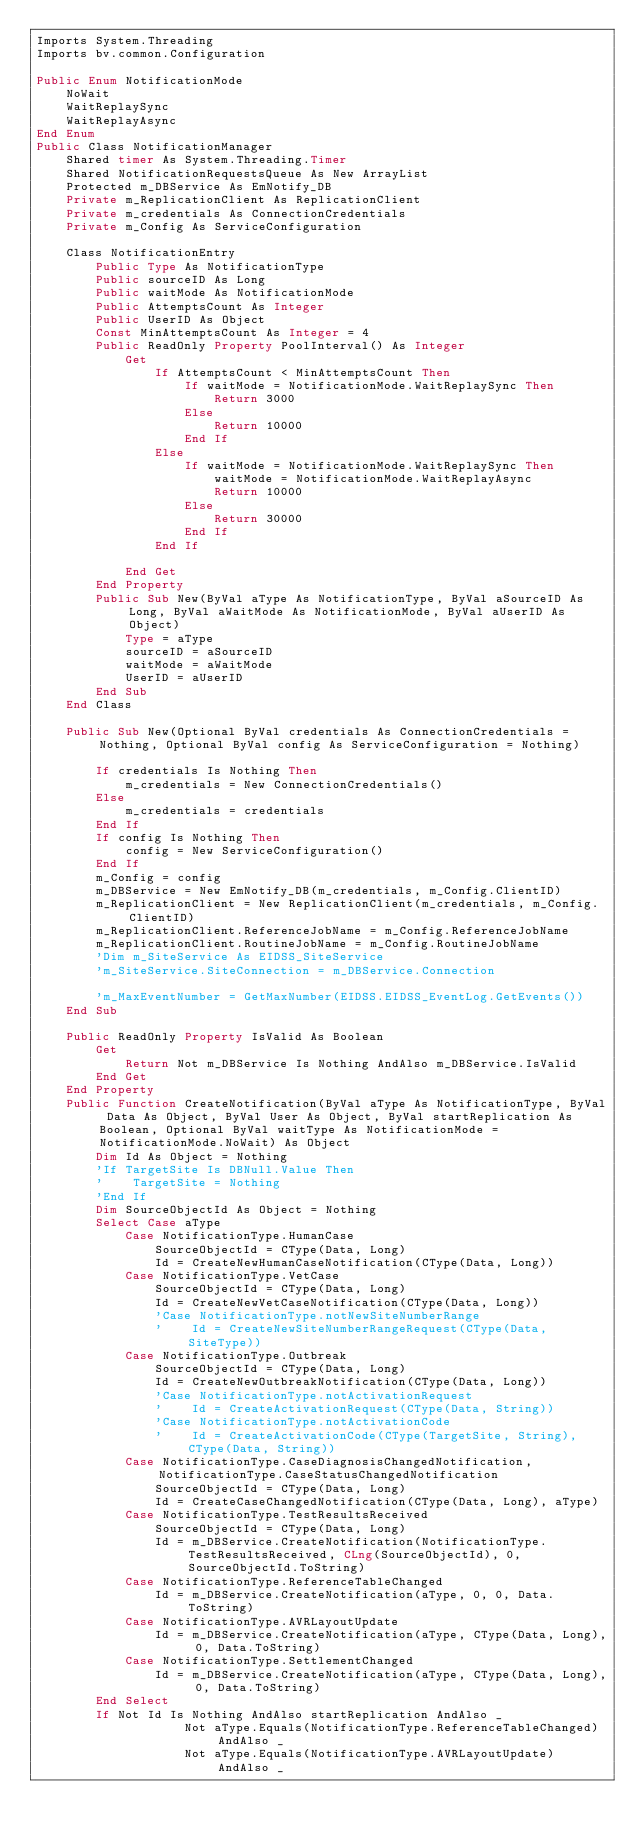<code> <loc_0><loc_0><loc_500><loc_500><_VisualBasic_>Imports System.Threading
Imports bv.common.Configuration

Public Enum NotificationMode
    NoWait
    WaitReplaySync
    WaitReplayAsync
End Enum
Public Class NotificationManager
    Shared timer As System.Threading.Timer
    Shared NotificationRequestsQueue As New ArrayList
    Protected m_DBService As EmNotify_DB
    Private m_ReplicationClient As ReplicationClient
    Private m_credentials As ConnectionCredentials
    Private m_Config As ServiceConfiguration

    Class NotificationEntry
        Public Type As NotificationType
        Public sourceID As Long
        Public waitMode As NotificationMode
        Public AttemptsCount As Integer
        Public UserID As Object
        Const MinAttemptsCount As Integer = 4
        Public ReadOnly Property PoolInterval() As Integer
            Get
                If AttemptsCount < MinAttemptsCount Then
                    If waitMode = NotificationMode.WaitReplaySync Then
                        Return 3000
                    Else
                        Return 10000
                    End If
                Else
                    If waitMode = NotificationMode.WaitReplaySync Then
                        waitMode = NotificationMode.WaitReplayAsync
                        Return 10000
                    Else
                        Return 30000
                    End If
                End If

            End Get
        End Property
        Public Sub New(ByVal aType As NotificationType, ByVal aSourceID As Long, ByVal aWaitMode As NotificationMode, ByVal aUserID As Object)
            Type = aType
            sourceID = aSourceID
            waitMode = aWaitMode
            UserID = aUserID
        End Sub
    End Class

    Public Sub New(Optional ByVal credentials As ConnectionCredentials = Nothing, Optional ByVal config As ServiceConfiguration = Nothing)

        If credentials Is Nothing Then
            m_credentials = New ConnectionCredentials()
        Else
            m_credentials = credentials
        End If
        If config Is Nothing Then
            config = New ServiceConfiguration()
        End If
        m_Config = config
        m_DBService = New EmNotify_DB(m_credentials, m_Config.ClientID)
        m_ReplicationClient = New ReplicationClient(m_credentials, m_Config.ClientID)
        m_ReplicationClient.ReferenceJobName = m_Config.ReferenceJobName
        m_ReplicationClient.RoutineJobName = m_Config.RoutineJobName
        'Dim m_SiteService As EIDSS_SiteService
        'm_SiteService.SiteConnection = m_DBService.Connection

        'm_MaxEventNumber = GetMaxNumber(EIDSS.EIDSS_EventLog.GetEvents())
    End Sub

    Public ReadOnly Property IsValid As Boolean
        Get
            Return Not m_DBService Is Nothing AndAlso m_DBService.IsValid
        End Get
    End Property
    Public Function CreateNotification(ByVal aType As NotificationType, ByVal Data As Object, ByVal User As Object, ByVal startReplication As Boolean, Optional ByVal waitType As NotificationMode = NotificationMode.NoWait) As Object
        Dim Id As Object = Nothing
        'If TargetSite Is DBNull.Value Then
        '    TargetSite = Nothing
        'End If
        Dim SourceObjectId As Object = Nothing
        Select Case aType
            Case NotificationType.HumanCase
                SourceObjectId = CType(Data, Long)
                Id = CreateNewHumanCaseNotification(CType(Data, Long))
            Case NotificationType.VetCase
                SourceObjectId = CType(Data, Long)
                Id = CreateNewVetCaseNotification(CType(Data, Long))
                'Case NotificationType.notNewSiteNumberRange
                '    Id = CreateNewSiteNumberRangeRequest(CType(Data, SiteType))
            Case NotificationType.Outbreak
                SourceObjectId = CType(Data, Long)
                Id = CreateNewOutbreakNotification(CType(Data, Long))
                'Case NotificationType.notActivationRequest
                '    Id = CreateActivationRequest(CType(Data, String))
                'Case NotificationType.notActivationCode
                '    Id = CreateActivationCode(CType(TargetSite, String), CType(Data, String))
            Case NotificationType.CaseDiagnosisChangedNotification, NotificationType.CaseStatusChangedNotification
                SourceObjectId = CType(Data, Long)
                Id = CreateCaseChangedNotification(CType(Data, Long), aType)
            Case NotificationType.TestResultsReceived
                SourceObjectId = CType(Data, Long)
                Id = m_DBService.CreateNotification(NotificationType.TestResultsReceived, CLng(SourceObjectId), 0, SourceObjectId.ToString)
            Case NotificationType.ReferenceTableChanged
                Id = m_DBService.CreateNotification(aType, 0, 0, Data.ToString)
            Case NotificationType.AVRLayoutUpdate
                Id = m_DBService.CreateNotification(aType, CType(Data, Long), 0, Data.ToString)
            Case NotificationType.SettlementChanged
                Id = m_DBService.CreateNotification(aType, CType(Data, Long), 0, Data.ToString)
        End Select
        If Not Id Is Nothing AndAlso startReplication AndAlso _
                    Not aType.Equals(NotificationType.ReferenceTableChanged) AndAlso _
                    Not aType.Equals(NotificationType.AVRLayoutUpdate) AndAlso _</code> 